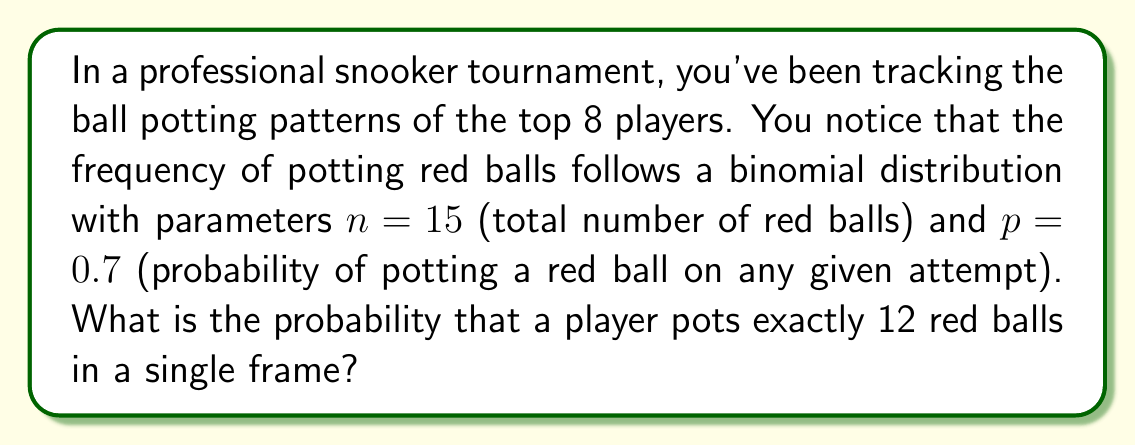Show me your answer to this math problem. To solve this problem, we'll use the binomial probability formula:

$$P(X = k) = \binom{n}{k} p^k (1-p)^{n-k}$$

Where:
$n = 15$ (total number of red balls)
$k = 12$ (number of successful pots we're interested in)
$p = 0.7$ (probability of potting a red ball)

Step 1: Calculate the binomial coefficient
$$\binom{15}{12} = \frac{15!}{12!(15-12)!} = \frac{15!}{12!3!} = 455$$

Step 2: Calculate $p^k$
$$0.7^{12} \approx 0.0138$$

Step 3: Calculate $(1-p)^{n-k}$
$$(1-0.7)^{15-12} = 0.3^3 = 0.027$$

Step 4: Multiply all parts together
$$455 \times 0.0138 \times 0.027 \approx 0.1693$$

Therefore, the probability of potting exactly 12 red balls in a single frame is approximately 0.1693 or 16.93%.
Answer: $0.1693$ 